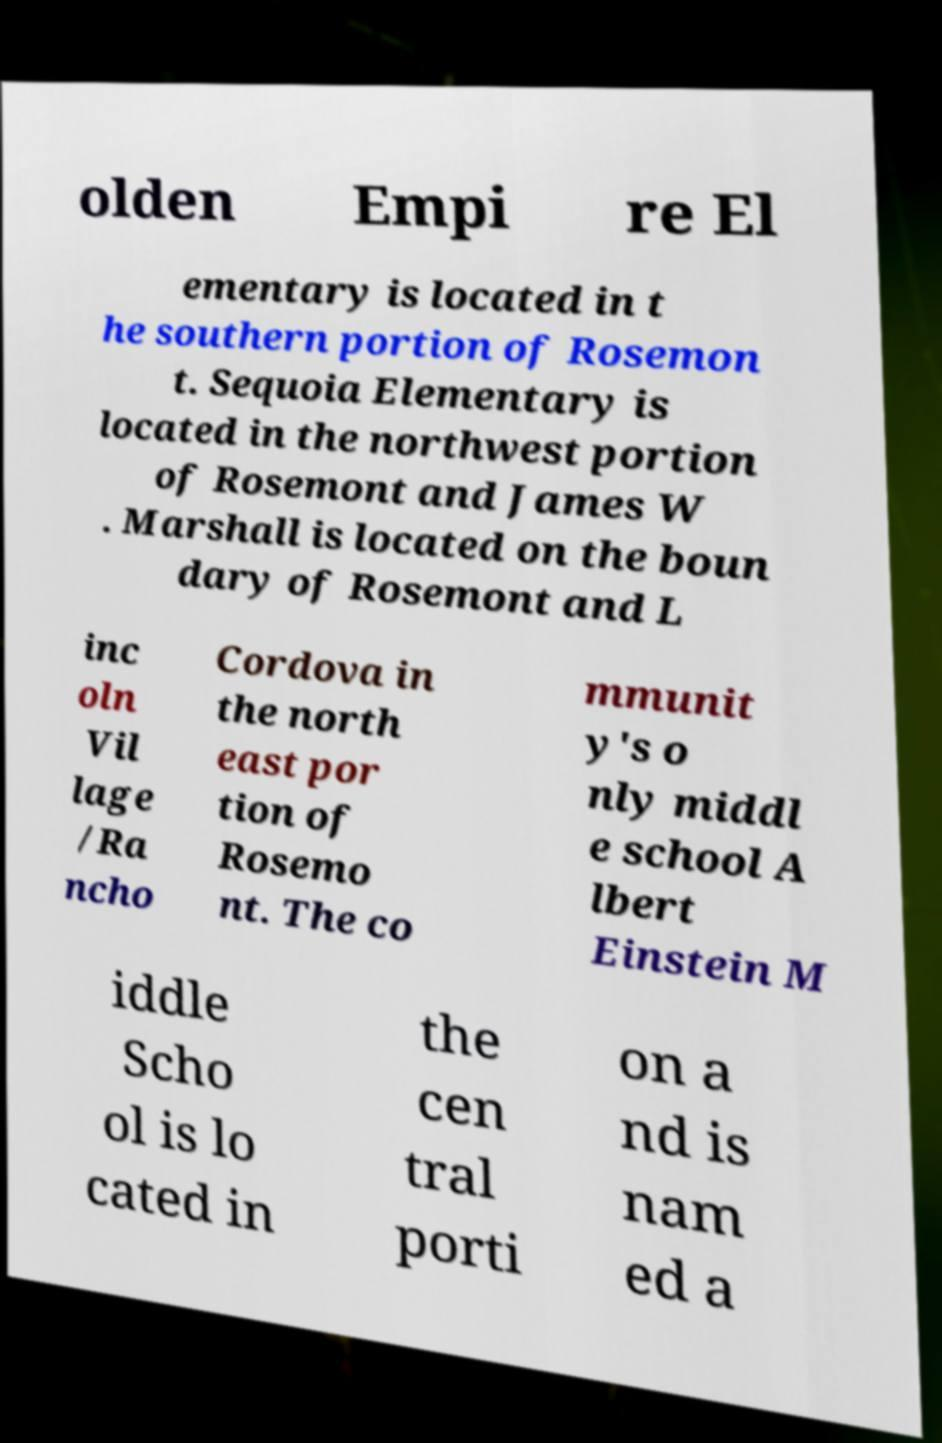Can you accurately transcribe the text from the provided image for me? olden Empi re El ementary is located in t he southern portion of Rosemon t. Sequoia Elementary is located in the northwest portion of Rosemont and James W . Marshall is located on the boun dary of Rosemont and L inc oln Vil lage /Ra ncho Cordova in the north east por tion of Rosemo nt. The co mmunit y's o nly middl e school A lbert Einstein M iddle Scho ol is lo cated in the cen tral porti on a nd is nam ed a 